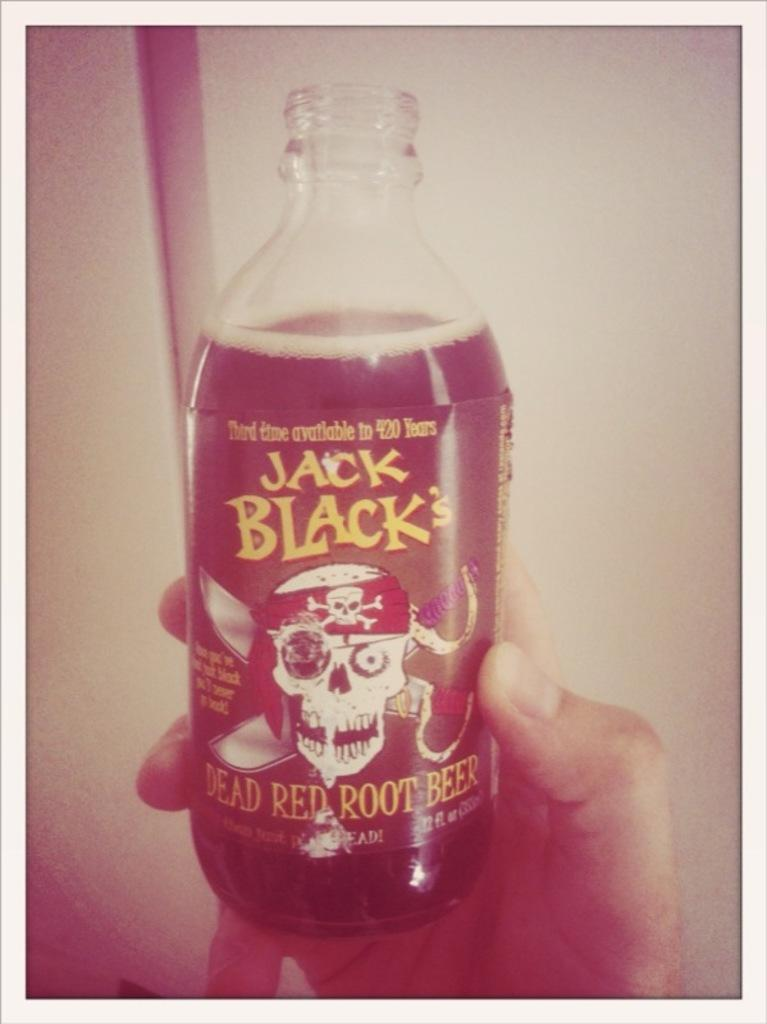Provide a one-sentence caption for the provided image. Hand holding a can of Jack Black Dead Red Root Beer. 